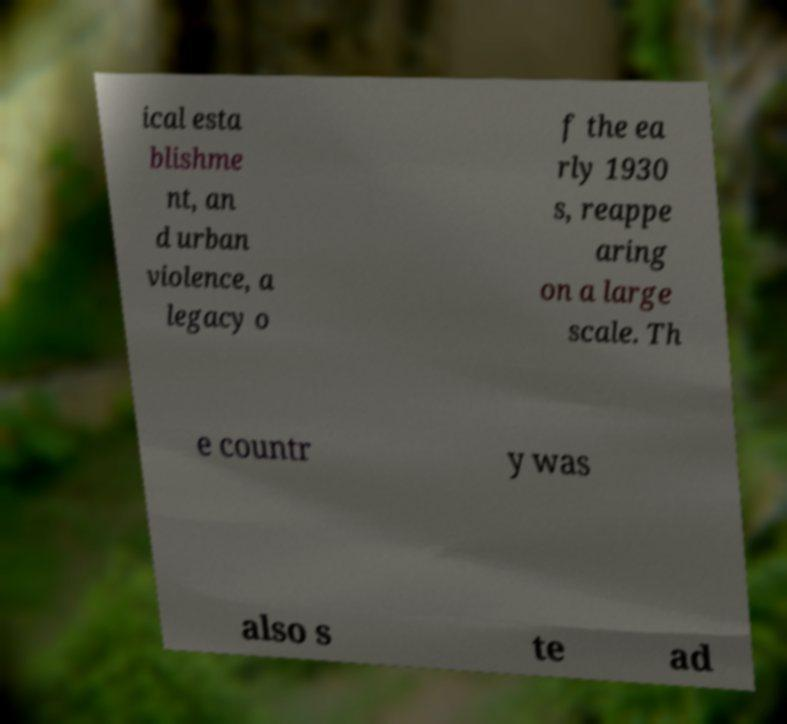Please read and relay the text visible in this image. What does it say? ical esta blishme nt, an d urban violence, a legacy o f the ea rly 1930 s, reappe aring on a large scale. Th e countr y was also s te ad 